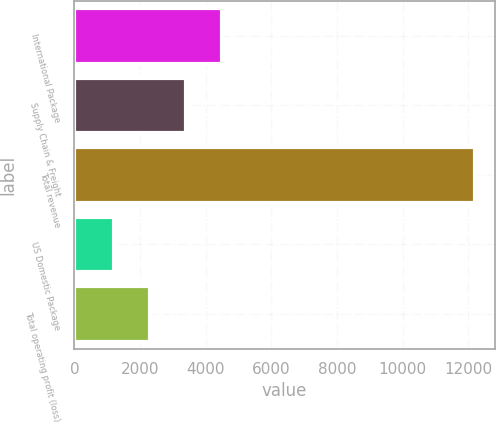<chart> <loc_0><loc_0><loc_500><loc_500><bar_chart><fcel>International Package<fcel>Supply Chain & Freight<fcel>Total revenue<fcel>US Domestic Package<fcel>Total operating profit (loss)<nl><fcel>4491.1<fcel>3391.4<fcel>12189<fcel>1192<fcel>2291.7<nl></chart> 